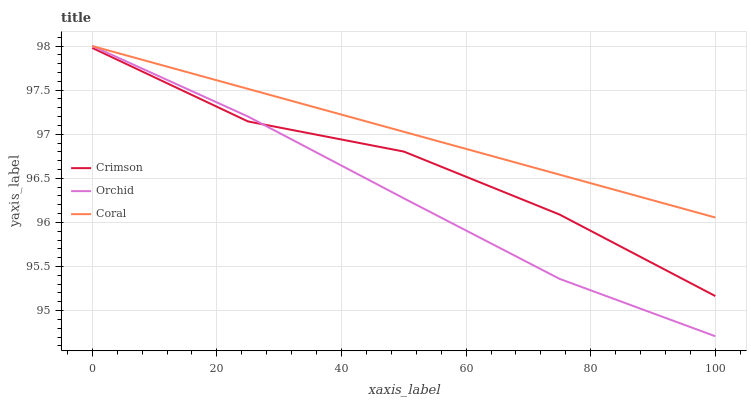Does Orchid have the minimum area under the curve?
Answer yes or no. Yes. Does Coral have the maximum area under the curve?
Answer yes or no. Yes. Does Coral have the minimum area under the curve?
Answer yes or no. No. Does Orchid have the maximum area under the curve?
Answer yes or no. No. Is Coral the smoothest?
Answer yes or no. Yes. Is Crimson the roughest?
Answer yes or no. Yes. Is Orchid the smoothest?
Answer yes or no. No. Is Orchid the roughest?
Answer yes or no. No. Does Coral have the lowest value?
Answer yes or no. No. Does Orchid have the highest value?
Answer yes or no. Yes. Is Crimson less than Coral?
Answer yes or no. Yes. Is Coral greater than Crimson?
Answer yes or no. Yes. Does Orchid intersect Crimson?
Answer yes or no. Yes. Is Orchid less than Crimson?
Answer yes or no. No. Is Orchid greater than Crimson?
Answer yes or no. No. Does Crimson intersect Coral?
Answer yes or no. No. 